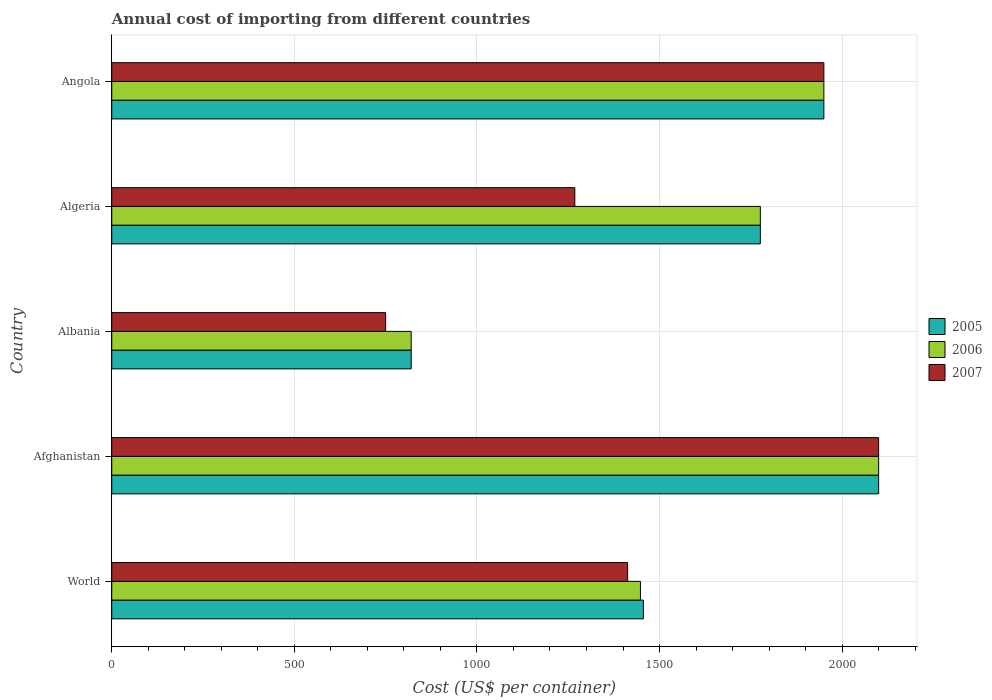How many groups of bars are there?
Offer a very short reply. 5. Are the number of bars on each tick of the Y-axis equal?
Give a very brief answer. Yes. How many bars are there on the 2nd tick from the top?
Keep it short and to the point. 3. How many bars are there on the 3rd tick from the bottom?
Your response must be concise. 3. In how many cases, is the number of bars for a given country not equal to the number of legend labels?
Provide a short and direct response. 0. What is the total annual cost of importing in 2006 in Afghanistan?
Provide a short and direct response. 2100. Across all countries, what is the maximum total annual cost of importing in 2007?
Your response must be concise. 2100. Across all countries, what is the minimum total annual cost of importing in 2005?
Provide a succinct answer. 820. In which country was the total annual cost of importing in 2005 maximum?
Offer a very short reply. Afghanistan. In which country was the total annual cost of importing in 2007 minimum?
Provide a succinct answer. Albania. What is the total total annual cost of importing in 2006 in the graph?
Make the answer very short. 8093.74. What is the difference between the total annual cost of importing in 2006 in Afghanistan and that in Albania?
Your response must be concise. 1280. What is the difference between the total annual cost of importing in 2005 in World and the total annual cost of importing in 2006 in Angola?
Provide a succinct answer. -494.15. What is the average total annual cost of importing in 2005 per country?
Provide a succinct answer. 1620.37. What is the ratio of the total annual cost of importing in 2006 in Albania to that in Angola?
Your answer should be very brief. 0.42. Is the total annual cost of importing in 2006 in Algeria less than that in World?
Keep it short and to the point. No. What is the difference between the highest and the second highest total annual cost of importing in 2007?
Provide a succinct answer. 150. What is the difference between the highest and the lowest total annual cost of importing in 2007?
Give a very brief answer. 1350. In how many countries, is the total annual cost of importing in 2007 greater than the average total annual cost of importing in 2007 taken over all countries?
Give a very brief answer. 2. Is the sum of the total annual cost of importing in 2005 in Afghanistan and Angola greater than the maximum total annual cost of importing in 2007 across all countries?
Your answer should be very brief. Yes. What does the 3rd bar from the top in Albania represents?
Ensure brevity in your answer.  2005. What does the 3rd bar from the bottom in Albania represents?
Provide a succinct answer. 2007. Are all the bars in the graph horizontal?
Offer a terse response. Yes. How are the legend labels stacked?
Ensure brevity in your answer.  Vertical. What is the title of the graph?
Provide a succinct answer. Annual cost of importing from different countries. What is the label or title of the X-axis?
Provide a short and direct response. Cost (US$ per container). What is the label or title of the Y-axis?
Provide a succinct answer. Country. What is the Cost (US$ per container) of 2005 in World?
Your answer should be very brief. 1455.85. What is the Cost (US$ per container) of 2006 in World?
Your answer should be very brief. 1447.74. What is the Cost (US$ per container) in 2007 in World?
Provide a succinct answer. 1412.62. What is the Cost (US$ per container) in 2005 in Afghanistan?
Your answer should be very brief. 2100. What is the Cost (US$ per container) of 2006 in Afghanistan?
Make the answer very short. 2100. What is the Cost (US$ per container) of 2007 in Afghanistan?
Provide a short and direct response. 2100. What is the Cost (US$ per container) in 2005 in Albania?
Offer a very short reply. 820. What is the Cost (US$ per container) of 2006 in Albania?
Give a very brief answer. 820. What is the Cost (US$ per container) in 2007 in Albania?
Offer a terse response. 750. What is the Cost (US$ per container) in 2005 in Algeria?
Your answer should be compact. 1776. What is the Cost (US$ per container) of 2006 in Algeria?
Offer a terse response. 1776. What is the Cost (US$ per container) of 2007 in Algeria?
Give a very brief answer. 1268. What is the Cost (US$ per container) of 2005 in Angola?
Ensure brevity in your answer.  1950. What is the Cost (US$ per container) of 2006 in Angola?
Make the answer very short. 1950. What is the Cost (US$ per container) in 2007 in Angola?
Your answer should be very brief. 1950. Across all countries, what is the maximum Cost (US$ per container) in 2005?
Your answer should be compact. 2100. Across all countries, what is the maximum Cost (US$ per container) of 2006?
Your answer should be very brief. 2100. Across all countries, what is the maximum Cost (US$ per container) of 2007?
Provide a short and direct response. 2100. Across all countries, what is the minimum Cost (US$ per container) of 2005?
Provide a short and direct response. 820. Across all countries, what is the minimum Cost (US$ per container) of 2006?
Offer a terse response. 820. Across all countries, what is the minimum Cost (US$ per container) of 2007?
Give a very brief answer. 750. What is the total Cost (US$ per container) in 2005 in the graph?
Offer a terse response. 8101.85. What is the total Cost (US$ per container) in 2006 in the graph?
Your answer should be very brief. 8093.74. What is the total Cost (US$ per container) of 2007 in the graph?
Make the answer very short. 7480.62. What is the difference between the Cost (US$ per container) of 2005 in World and that in Afghanistan?
Ensure brevity in your answer.  -644.15. What is the difference between the Cost (US$ per container) in 2006 in World and that in Afghanistan?
Ensure brevity in your answer.  -652.26. What is the difference between the Cost (US$ per container) of 2007 in World and that in Afghanistan?
Your response must be concise. -687.38. What is the difference between the Cost (US$ per container) in 2005 in World and that in Albania?
Your response must be concise. 635.85. What is the difference between the Cost (US$ per container) of 2006 in World and that in Albania?
Make the answer very short. 627.74. What is the difference between the Cost (US$ per container) of 2007 in World and that in Albania?
Offer a terse response. 662.62. What is the difference between the Cost (US$ per container) in 2005 in World and that in Algeria?
Ensure brevity in your answer.  -320.15. What is the difference between the Cost (US$ per container) of 2006 in World and that in Algeria?
Provide a succinct answer. -328.26. What is the difference between the Cost (US$ per container) in 2007 in World and that in Algeria?
Your answer should be compact. 144.62. What is the difference between the Cost (US$ per container) in 2005 in World and that in Angola?
Your response must be concise. -494.15. What is the difference between the Cost (US$ per container) in 2006 in World and that in Angola?
Give a very brief answer. -502.26. What is the difference between the Cost (US$ per container) in 2007 in World and that in Angola?
Offer a terse response. -537.38. What is the difference between the Cost (US$ per container) of 2005 in Afghanistan and that in Albania?
Offer a very short reply. 1280. What is the difference between the Cost (US$ per container) of 2006 in Afghanistan and that in Albania?
Your answer should be very brief. 1280. What is the difference between the Cost (US$ per container) of 2007 in Afghanistan and that in Albania?
Your answer should be compact. 1350. What is the difference between the Cost (US$ per container) in 2005 in Afghanistan and that in Algeria?
Keep it short and to the point. 324. What is the difference between the Cost (US$ per container) of 2006 in Afghanistan and that in Algeria?
Offer a very short reply. 324. What is the difference between the Cost (US$ per container) of 2007 in Afghanistan and that in Algeria?
Your response must be concise. 832. What is the difference between the Cost (US$ per container) in 2005 in Afghanistan and that in Angola?
Provide a succinct answer. 150. What is the difference between the Cost (US$ per container) in 2006 in Afghanistan and that in Angola?
Your response must be concise. 150. What is the difference between the Cost (US$ per container) in 2007 in Afghanistan and that in Angola?
Give a very brief answer. 150. What is the difference between the Cost (US$ per container) in 2005 in Albania and that in Algeria?
Offer a very short reply. -956. What is the difference between the Cost (US$ per container) in 2006 in Albania and that in Algeria?
Provide a short and direct response. -956. What is the difference between the Cost (US$ per container) in 2007 in Albania and that in Algeria?
Your response must be concise. -518. What is the difference between the Cost (US$ per container) of 2005 in Albania and that in Angola?
Make the answer very short. -1130. What is the difference between the Cost (US$ per container) of 2006 in Albania and that in Angola?
Provide a succinct answer. -1130. What is the difference between the Cost (US$ per container) of 2007 in Albania and that in Angola?
Make the answer very short. -1200. What is the difference between the Cost (US$ per container) of 2005 in Algeria and that in Angola?
Offer a very short reply. -174. What is the difference between the Cost (US$ per container) of 2006 in Algeria and that in Angola?
Make the answer very short. -174. What is the difference between the Cost (US$ per container) in 2007 in Algeria and that in Angola?
Your answer should be compact. -682. What is the difference between the Cost (US$ per container) in 2005 in World and the Cost (US$ per container) in 2006 in Afghanistan?
Your response must be concise. -644.15. What is the difference between the Cost (US$ per container) of 2005 in World and the Cost (US$ per container) of 2007 in Afghanistan?
Your answer should be compact. -644.15. What is the difference between the Cost (US$ per container) of 2006 in World and the Cost (US$ per container) of 2007 in Afghanistan?
Make the answer very short. -652.26. What is the difference between the Cost (US$ per container) of 2005 in World and the Cost (US$ per container) of 2006 in Albania?
Make the answer very short. 635.85. What is the difference between the Cost (US$ per container) in 2005 in World and the Cost (US$ per container) in 2007 in Albania?
Ensure brevity in your answer.  705.85. What is the difference between the Cost (US$ per container) of 2006 in World and the Cost (US$ per container) of 2007 in Albania?
Your response must be concise. 697.74. What is the difference between the Cost (US$ per container) in 2005 in World and the Cost (US$ per container) in 2006 in Algeria?
Provide a short and direct response. -320.15. What is the difference between the Cost (US$ per container) in 2005 in World and the Cost (US$ per container) in 2007 in Algeria?
Offer a very short reply. 187.85. What is the difference between the Cost (US$ per container) of 2006 in World and the Cost (US$ per container) of 2007 in Algeria?
Make the answer very short. 179.74. What is the difference between the Cost (US$ per container) of 2005 in World and the Cost (US$ per container) of 2006 in Angola?
Give a very brief answer. -494.15. What is the difference between the Cost (US$ per container) of 2005 in World and the Cost (US$ per container) of 2007 in Angola?
Ensure brevity in your answer.  -494.15. What is the difference between the Cost (US$ per container) in 2006 in World and the Cost (US$ per container) in 2007 in Angola?
Your answer should be compact. -502.26. What is the difference between the Cost (US$ per container) of 2005 in Afghanistan and the Cost (US$ per container) of 2006 in Albania?
Offer a very short reply. 1280. What is the difference between the Cost (US$ per container) of 2005 in Afghanistan and the Cost (US$ per container) of 2007 in Albania?
Offer a very short reply. 1350. What is the difference between the Cost (US$ per container) in 2006 in Afghanistan and the Cost (US$ per container) in 2007 in Albania?
Your answer should be compact. 1350. What is the difference between the Cost (US$ per container) of 2005 in Afghanistan and the Cost (US$ per container) of 2006 in Algeria?
Your response must be concise. 324. What is the difference between the Cost (US$ per container) in 2005 in Afghanistan and the Cost (US$ per container) in 2007 in Algeria?
Offer a terse response. 832. What is the difference between the Cost (US$ per container) of 2006 in Afghanistan and the Cost (US$ per container) of 2007 in Algeria?
Your response must be concise. 832. What is the difference between the Cost (US$ per container) in 2005 in Afghanistan and the Cost (US$ per container) in 2006 in Angola?
Make the answer very short. 150. What is the difference between the Cost (US$ per container) of 2005 in Afghanistan and the Cost (US$ per container) of 2007 in Angola?
Your answer should be very brief. 150. What is the difference between the Cost (US$ per container) in 2006 in Afghanistan and the Cost (US$ per container) in 2007 in Angola?
Offer a very short reply. 150. What is the difference between the Cost (US$ per container) in 2005 in Albania and the Cost (US$ per container) in 2006 in Algeria?
Provide a short and direct response. -956. What is the difference between the Cost (US$ per container) of 2005 in Albania and the Cost (US$ per container) of 2007 in Algeria?
Your response must be concise. -448. What is the difference between the Cost (US$ per container) in 2006 in Albania and the Cost (US$ per container) in 2007 in Algeria?
Make the answer very short. -448. What is the difference between the Cost (US$ per container) in 2005 in Albania and the Cost (US$ per container) in 2006 in Angola?
Keep it short and to the point. -1130. What is the difference between the Cost (US$ per container) in 2005 in Albania and the Cost (US$ per container) in 2007 in Angola?
Keep it short and to the point. -1130. What is the difference between the Cost (US$ per container) in 2006 in Albania and the Cost (US$ per container) in 2007 in Angola?
Your response must be concise. -1130. What is the difference between the Cost (US$ per container) in 2005 in Algeria and the Cost (US$ per container) in 2006 in Angola?
Provide a short and direct response. -174. What is the difference between the Cost (US$ per container) in 2005 in Algeria and the Cost (US$ per container) in 2007 in Angola?
Provide a succinct answer. -174. What is the difference between the Cost (US$ per container) in 2006 in Algeria and the Cost (US$ per container) in 2007 in Angola?
Make the answer very short. -174. What is the average Cost (US$ per container) in 2005 per country?
Ensure brevity in your answer.  1620.37. What is the average Cost (US$ per container) in 2006 per country?
Your response must be concise. 1618.75. What is the average Cost (US$ per container) in 2007 per country?
Provide a short and direct response. 1496.12. What is the difference between the Cost (US$ per container) in 2005 and Cost (US$ per container) in 2006 in World?
Keep it short and to the point. 8.11. What is the difference between the Cost (US$ per container) of 2005 and Cost (US$ per container) of 2007 in World?
Offer a terse response. 43.23. What is the difference between the Cost (US$ per container) of 2006 and Cost (US$ per container) of 2007 in World?
Offer a terse response. 35.12. What is the difference between the Cost (US$ per container) in 2006 and Cost (US$ per container) in 2007 in Afghanistan?
Make the answer very short. 0. What is the difference between the Cost (US$ per container) in 2005 and Cost (US$ per container) in 2007 in Albania?
Give a very brief answer. 70. What is the difference between the Cost (US$ per container) in 2005 and Cost (US$ per container) in 2006 in Algeria?
Ensure brevity in your answer.  0. What is the difference between the Cost (US$ per container) of 2005 and Cost (US$ per container) of 2007 in Algeria?
Your answer should be compact. 508. What is the difference between the Cost (US$ per container) of 2006 and Cost (US$ per container) of 2007 in Algeria?
Offer a terse response. 508. What is the difference between the Cost (US$ per container) of 2006 and Cost (US$ per container) of 2007 in Angola?
Provide a short and direct response. 0. What is the ratio of the Cost (US$ per container) in 2005 in World to that in Afghanistan?
Your answer should be compact. 0.69. What is the ratio of the Cost (US$ per container) of 2006 in World to that in Afghanistan?
Offer a terse response. 0.69. What is the ratio of the Cost (US$ per container) of 2007 in World to that in Afghanistan?
Your answer should be compact. 0.67. What is the ratio of the Cost (US$ per container) of 2005 in World to that in Albania?
Give a very brief answer. 1.78. What is the ratio of the Cost (US$ per container) in 2006 in World to that in Albania?
Keep it short and to the point. 1.77. What is the ratio of the Cost (US$ per container) in 2007 in World to that in Albania?
Provide a succinct answer. 1.88. What is the ratio of the Cost (US$ per container) of 2005 in World to that in Algeria?
Provide a short and direct response. 0.82. What is the ratio of the Cost (US$ per container) of 2006 in World to that in Algeria?
Give a very brief answer. 0.82. What is the ratio of the Cost (US$ per container) in 2007 in World to that in Algeria?
Give a very brief answer. 1.11. What is the ratio of the Cost (US$ per container) of 2005 in World to that in Angola?
Offer a terse response. 0.75. What is the ratio of the Cost (US$ per container) in 2006 in World to that in Angola?
Your response must be concise. 0.74. What is the ratio of the Cost (US$ per container) of 2007 in World to that in Angola?
Your answer should be compact. 0.72. What is the ratio of the Cost (US$ per container) in 2005 in Afghanistan to that in Albania?
Provide a succinct answer. 2.56. What is the ratio of the Cost (US$ per container) of 2006 in Afghanistan to that in Albania?
Keep it short and to the point. 2.56. What is the ratio of the Cost (US$ per container) in 2007 in Afghanistan to that in Albania?
Offer a terse response. 2.8. What is the ratio of the Cost (US$ per container) in 2005 in Afghanistan to that in Algeria?
Offer a terse response. 1.18. What is the ratio of the Cost (US$ per container) in 2006 in Afghanistan to that in Algeria?
Provide a short and direct response. 1.18. What is the ratio of the Cost (US$ per container) in 2007 in Afghanistan to that in Algeria?
Keep it short and to the point. 1.66. What is the ratio of the Cost (US$ per container) of 2006 in Afghanistan to that in Angola?
Provide a succinct answer. 1.08. What is the ratio of the Cost (US$ per container) of 2005 in Albania to that in Algeria?
Keep it short and to the point. 0.46. What is the ratio of the Cost (US$ per container) in 2006 in Albania to that in Algeria?
Your response must be concise. 0.46. What is the ratio of the Cost (US$ per container) in 2007 in Albania to that in Algeria?
Make the answer very short. 0.59. What is the ratio of the Cost (US$ per container) of 2005 in Albania to that in Angola?
Ensure brevity in your answer.  0.42. What is the ratio of the Cost (US$ per container) in 2006 in Albania to that in Angola?
Make the answer very short. 0.42. What is the ratio of the Cost (US$ per container) in 2007 in Albania to that in Angola?
Provide a short and direct response. 0.38. What is the ratio of the Cost (US$ per container) of 2005 in Algeria to that in Angola?
Your answer should be compact. 0.91. What is the ratio of the Cost (US$ per container) in 2006 in Algeria to that in Angola?
Provide a short and direct response. 0.91. What is the ratio of the Cost (US$ per container) of 2007 in Algeria to that in Angola?
Offer a very short reply. 0.65. What is the difference between the highest and the second highest Cost (US$ per container) of 2005?
Give a very brief answer. 150. What is the difference between the highest and the second highest Cost (US$ per container) of 2006?
Keep it short and to the point. 150. What is the difference between the highest and the second highest Cost (US$ per container) in 2007?
Your answer should be very brief. 150. What is the difference between the highest and the lowest Cost (US$ per container) in 2005?
Give a very brief answer. 1280. What is the difference between the highest and the lowest Cost (US$ per container) in 2006?
Your answer should be very brief. 1280. What is the difference between the highest and the lowest Cost (US$ per container) of 2007?
Offer a terse response. 1350. 